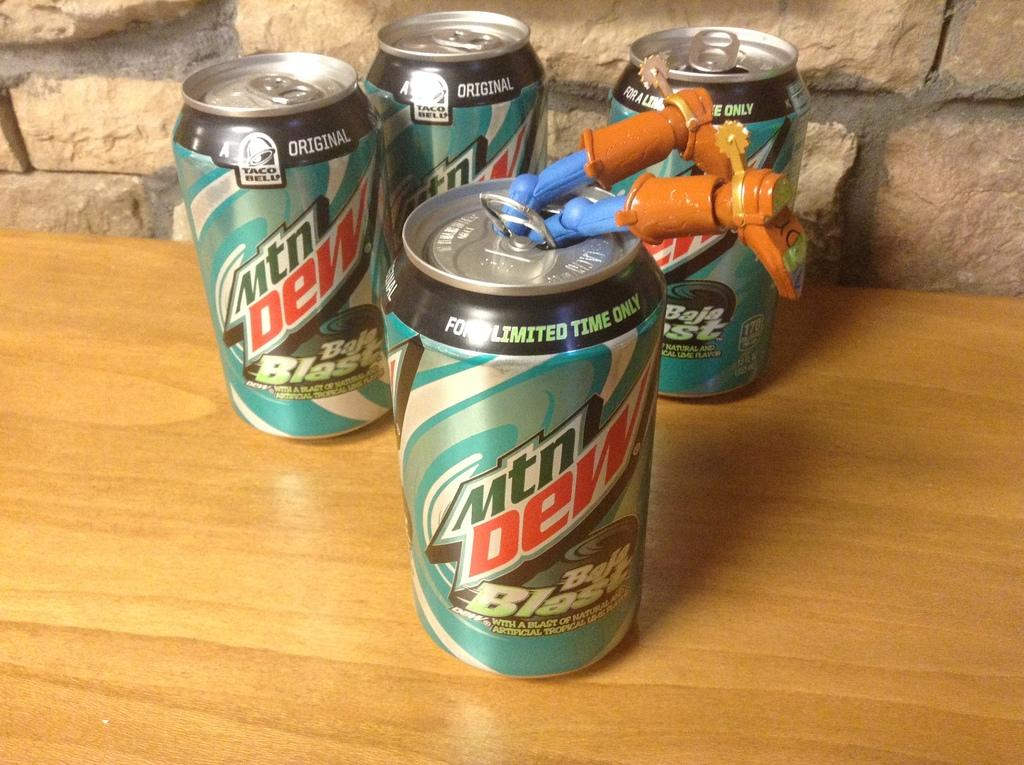Provide a one-sentence caption for the provided image. Limited edition cans of Mtn. Dew Baja Blast with the legs of Woody from Toy Story hanging out of one. 